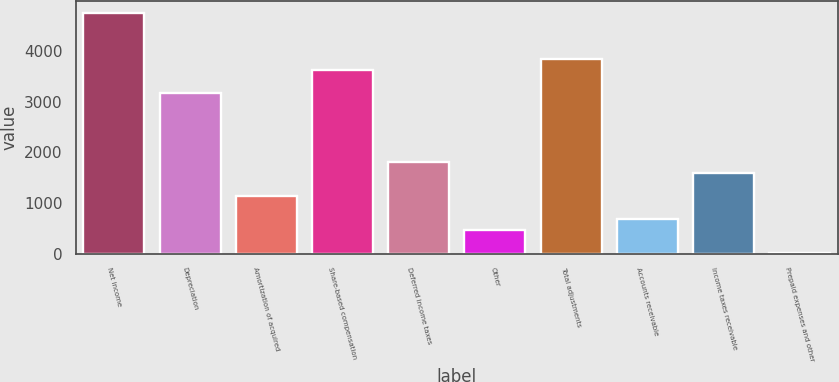<chart> <loc_0><loc_0><loc_500><loc_500><bar_chart><fcel>Net income<fcel>Depreciation<fcel>Amortization of acquired<fcel>Share-based compensation<fcel>Deferred income taxes<fcel>Other<fcel>Total adjustments<fcel>Accounts receivable<fcel>Income taxes receivable<fcel>Prepaid expenses and other<nl><fcel>4743.4<fcel>3165.6<fcel>1137<fcel>3616.4<fcel>1813.2<fcel>460.8<fcel>3841.8<fcel>686.2<fcel>1587.8<fcel>10<nl></chart> 